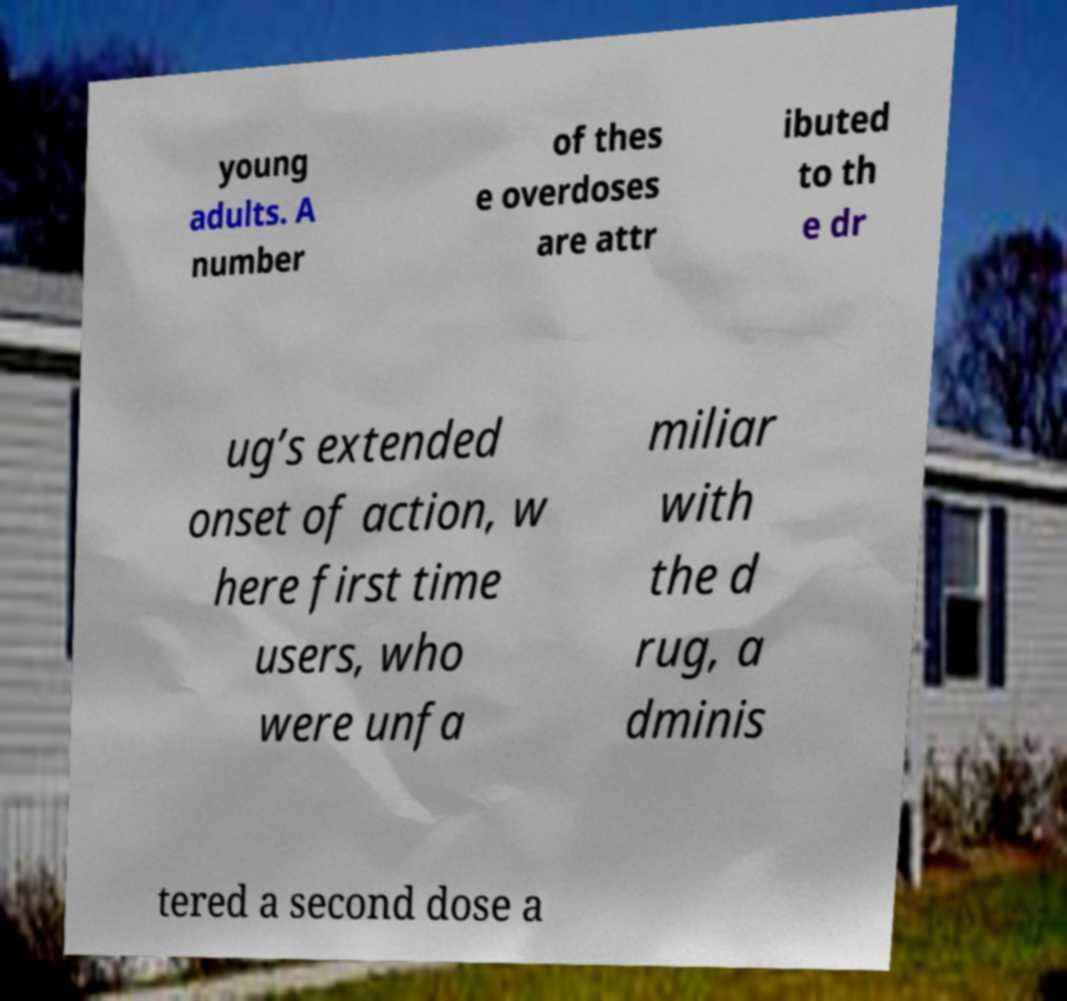Could you assist in decoding the text presented in this image and type it out clearly? young adults. A number of thes e overdoses are attr ibuted to th e dr ug’s extended onset of action, w here first time users, who were unfa miliar with the d rug, a dminis tered a second dose a 